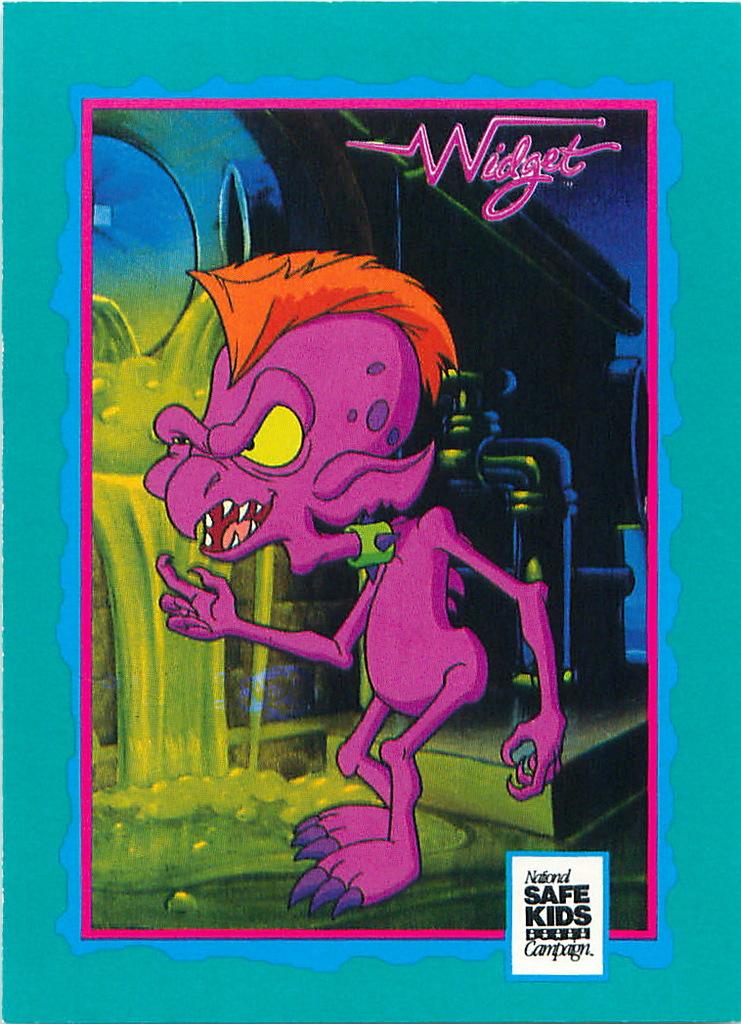What orginazation made this?
Your answer should be compact. National safe kids campaign. What is the title?
Provide a succinct answer. Widget. 